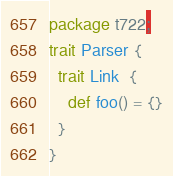Convert code to text. <code><loc_0><loc_0><loc_500><loc_500><_Scala_>
package t722;
trait Parser {
  trait Link  {
    def foo() = {}
  }
}

</code> 